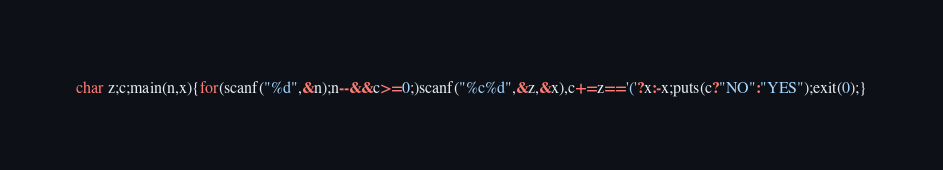Convert code to text. <code><loc_0><loc_0><loc_500><loc_500><_C_>char z;c;main(n,x){for(scanf("%d",&n);n--&&c>=0;)scanf("%c%d",&z,&x),c+=z=='('?x:-x;puts(c?"NO":"YES");exit(0);}</code> 